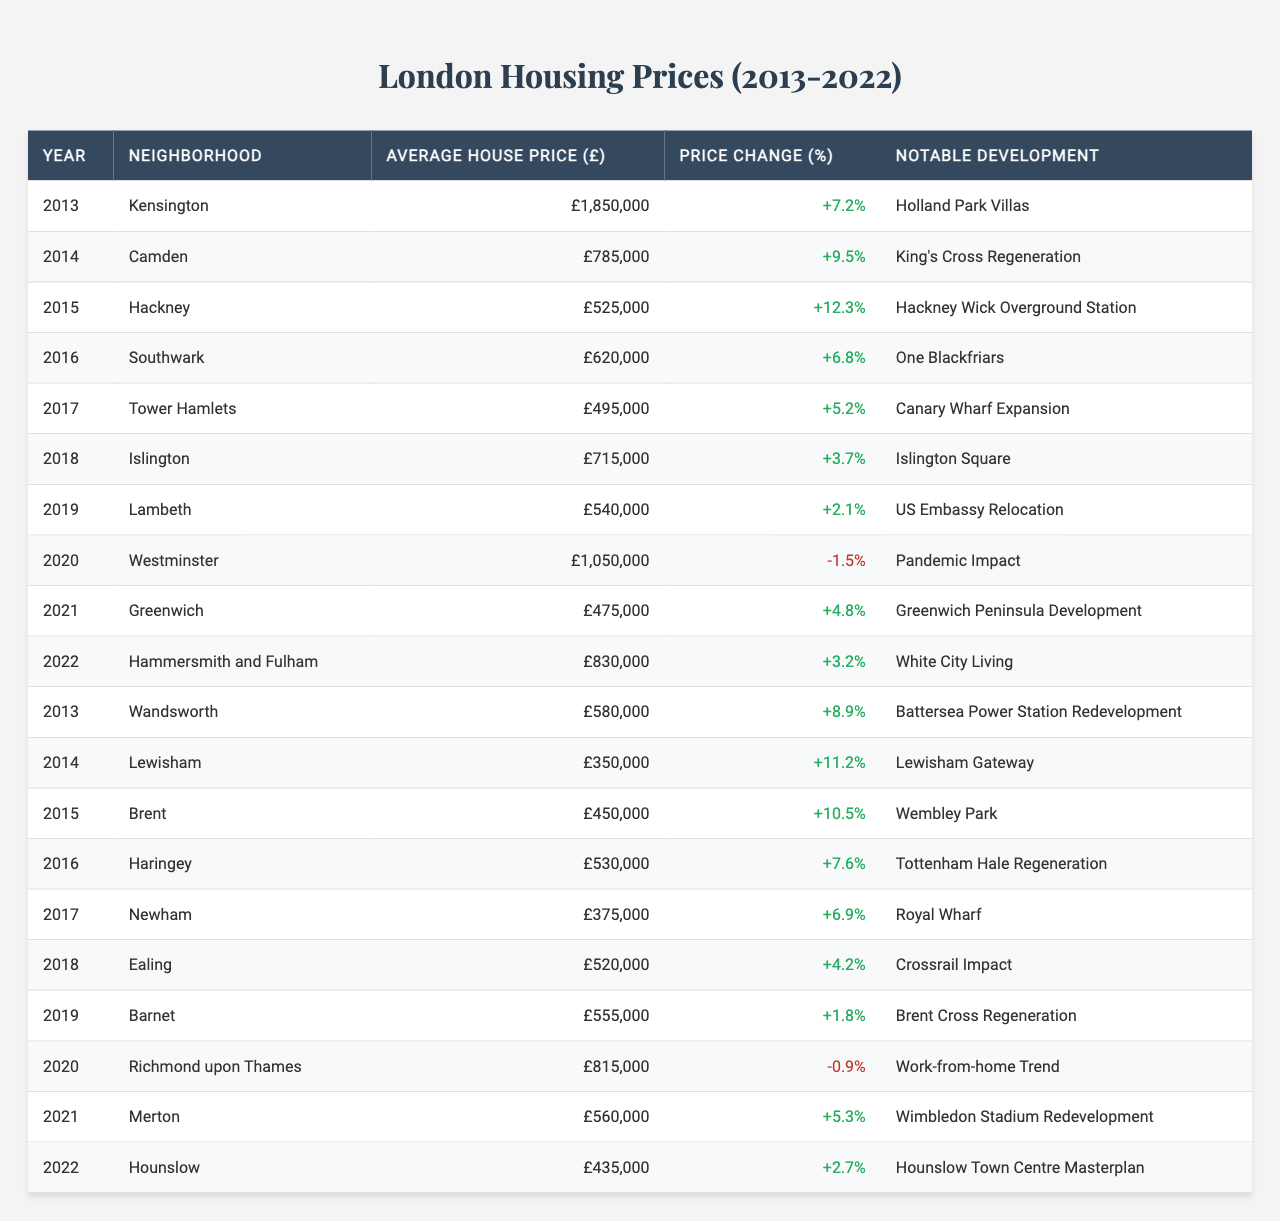What was the average house price in Kensington in 2013? The table shows that in 2013, the average house price in Kensington was £1,850,000.
Answer: £1,850,000 Which neighborhood experienced the highest average house price in 2020? According to the table, Westminster had the highest average house price in 2020 at £1,050,000.
Answer: Westminster Was there a price decrease in any neighborhood in 2020? Yes, the table indicates that in 2020, Westminster saw a price decrease of -1.5%.
Answer: Yes Which neighborhood saw the highest percentage price change over the decade? Reviewing the table, Hackney experienced the highest price change of 12.3% in 2015.
Answer: Hackney, 12.3% What is the total average house price in London neighborhoods for the year 2022? To find this, we sum the house prices for all neighborhoods in 2022 (£830,000 + £435,000) which equals £1,265,000.
Answer: £1,265,000 How much did the average house price in Islington increase from 2018 to 2019? In 2018, Islington had an average price of £715,000 and in 2019 it was £540,000, which represents a decrease of £175,000.
Answer: Decreased by £175,000 Which neighborhood had the lowest average house price over the entire decade? By analyzing the table, Newham had the lowest average house price in 2017 at £375,000.
Answer: Newham, £375,000 What was the notable development in Lambeth in 2019? The table lists the relocation of the US Embassy as the notable development in Lambeth for that year.
Answer: US Embassy Relocation Did any neighborhood have a consistent price increase from 2013 to 2022? Upon examination, no neighborhood consistently increased its price every year. For example, Westminster experienced a decrease in 2020.
Answer: No Which neighborhood had the greatest average house price in 2018 and what was it? The table indicates that in 2018, Hammersmith and Fulham had the highest average house price at £830,000.
Answer: Hammersmith and Fulham, £830,000 What was the average house price change in Southwark from 2016 to 2017? The average price in Southwark remained £620,000 in 2016 and £495,000 in Tower Hamlets for 2017, a decrease of £125,000.
Answer: Decreased by £125,000 